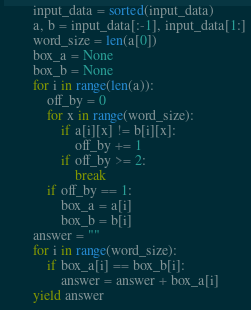<code> <loc_0><loc_0><loc_500><loc_500><_Python_>        input_data = sorted(input_data)
        a, b = input_data[:-1], input_data[1:]
        word_size = len(a[0])
        box_a = None
        box_b = None
        for i in range(len(a)):
            off_by = 0
            for x in range(word_size):
                if a[i][x] != b[i][x]:
                    off_by += 1
                if off_by >= 2:
                    break
            if off_by == 1:
                box_a = a[i]
                box_b = b[i]
        answer = ""
        for i in range(word_size):
            if box_a[i] == box_b[i]:
                answer = answer + box_a[i]
        yield answer
</code> 